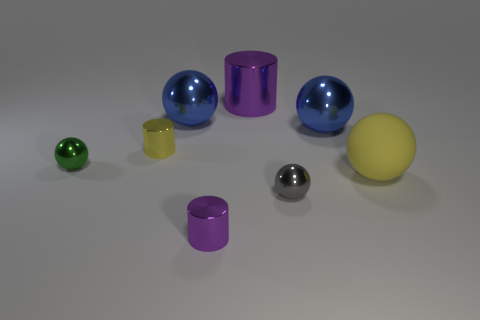There is a large thing that is the same shape as the small purple metal thing; what is its color?
Your answer should be compact. Purple. Does the large matte sphere have the same color as the small cylinder that is behind the yellow matte ball?
Offer a very short reply. Yes. What is the material of the big yellow ball?
Make the answer very short. Rubber. What number of other things are there of the same material as the yellow cylinder
Your answer should be very brief. 6. The thing that is behind the yellow shiny object and on the right side of the large purple cylinder has what shape?
Provide a succinct answer. Sphere. What color is the large cylinder that is made of the same material as the tiny gray thing?
Offer a terse response. Purple. Are there an equal number of rubber balls that are to the right of the tiny gray thing and matte spheres?
Provide a succinct answer. Yes. What shape is the purple thing that is the same size as the gray ball?
Your answer should be very brief. Cylinder. What number of other objects are the same shape as the rubber thing?
Your response must be concise. 4. Is the size of the gray shiny sphere the same as the metallic cylinder behind the tiny yellow metallic cylinder?
Your answer should be compact. No. 